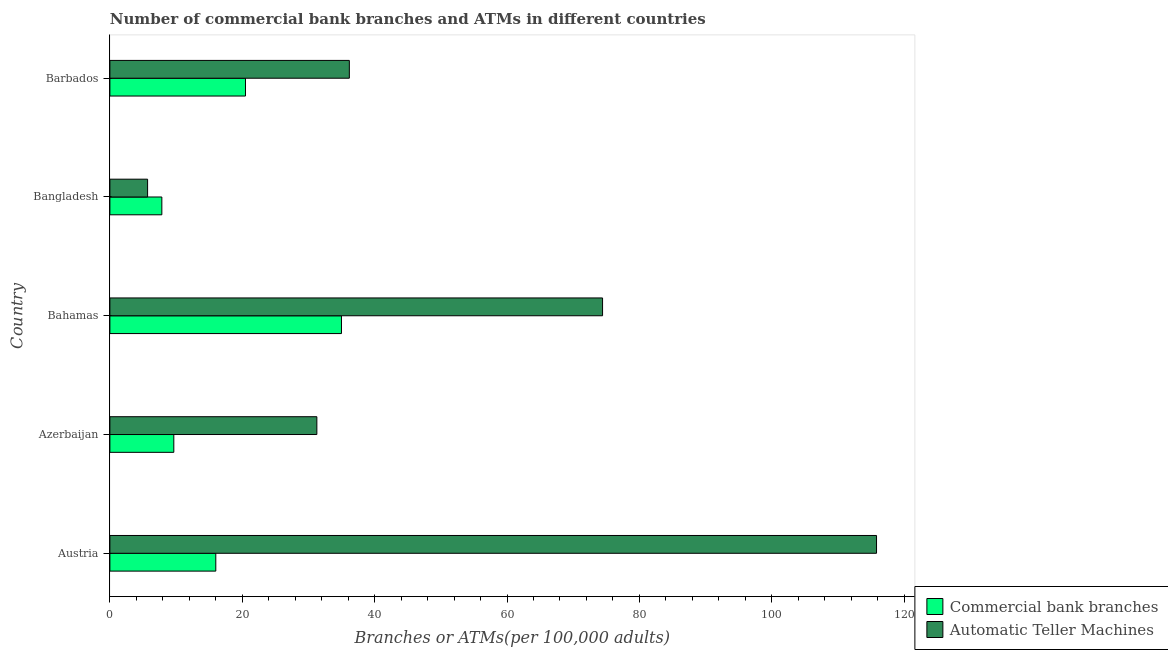How many groups of bars are there?
Offer a terse response. 5. Are the number of bars per tick equal to the number of legend labels?
Offer a very short reply. Yes. How many bars are there on the 2nd tick from the top?
Your answer should be very brief. 2. How many bars are there on the 2nd tick from the bottom?
Your answer should be very brief. 2. What is the label of the 5th group of bars from the top?
Your answer should be compact. Austria. What is the number of atms in Azerbaijan?
Provide a succinct answer. 31.27. Across all countries, what is the maximum number of commercal bank branches?
Your answer should be compact. 34.99. Across all countries, what is the minimum number of commercal bank branches?
Make the answer very short. 7.85. In which country was the number of commercal bank branches minimum?
Provide a short and direct response. Bangladesh. What is the total number of atms in the graph?
Offer a terse response. 263.4. What is the difference between the number of atms in Austria and that in Barbados?
Your response must be concise. 79.65. What is the difference between the number of atms in Azerbaijan and the number of commercal bank branches in Barbados?
Offer a terse response. 10.78. What is the average number of commercal bank branches per country?
Keep it short and to the point. 17.8. What is the difference between the number of commercal bank branches and number of atms in Austria?
Offer a terse response. -99.83. In how many countries, is the number of atms greater than 60 ?
Give a very brief answer. 2. What is the ratio of the number of commercal bank branches in Austria to that in Azerbaijan?
Your answer should be compact. 1.66. Is the number of atms in Austria less than that in Bahamas?
Provide a short and direct response. No. Is the difference between the number of atms in Austria and Barbados greater than the difference between the number of commercal bank branches in Austria and Barbados?
Make the answer very short. Yes. What is the difference between the highest and the second highest number of commercal bank branches?
Offer a very short reply. 14.5. What is the difference between the highest and the lowest number of commercal bank branches?
Offer a terse response. 27.14. In how many countries, is the number of atms greater than the average number of atms taken over all countries?
Offer a terse response. 2. Is the sum of the number of atms in Austria and Azerbaijan greater than the maximum number of commercal bank branches across all countries?
Ensure brevity in your answer.  Yes. What does the 1st bar from the top in Bangladesh represents?
Your response must be concise. Automatic Teller Machines. What does the 1st bar from the bottom in Barbados represents?
Ensure brevity in your answer.  Commercial bank branches. How many countries are there in the graph?
Provide a short and direct response. 5. Does the graph contain any zero values?
Make the answer very short. No. Does the graph contain grids?
Ensure brevity in your answer.  No. Where does the legend appear in the graph?
Give a very brief answer. Bottom right. How many legend labels are there?
Provide a succinct answer. 2. What is the title of the graph?
Keep it short and to the point. Number of commercial bank branches and ATMs in different countries. What is the label or title of the X-axis?
Your response must be concise. Branches or ATMs(per 100,0 adults). What is the Branches or ATMs(per 100,000 adults) in Commercial bank branches in Austria?
Keep it short and to the point. 16. What is the Branches or ATMs(per 100,000 adults) in Automatic Teller Machines in Austria?
Offer a very short reply. 115.83. What is the Branches or ATMs(per 100,000 adults) of Commercial bank branches in Azerbaijan?
Keep it short and to the point. 9.66. What is the Branches or ATMs(per 100,000 adults) of Automatic Teller Machines in Azerbaijan?
Give a very brief answer. 31.27. What is the Branches or ATMs(per 100,000 adults) of Commercial bank branches in Bahamas?
Your answer should be very brief. 34.99. What is the Branches or ATMs(per 100,000 adults) in Automatic Teller Machines in Bahamas?
Give a very brief answer. 74.43. What is the Branches or ATMs(per 100,000 adults) in Commercial bank branches in Bangladesh?
Provide a short and direct response. 7.85. What is the Branches or ATMs(per 100,000 adults) of Automatic Teller Machines in Bangladesh?
Ensure brevity in your answer.  5.7. What is the Branches or ATMs(per 100,000 adults) of Commercial bank branches in Barbados?
Provide a succinct answer. 20.49. What is the Branches or ATMs(per 100,000 adults) in Automatic Teller Machines in Barbados?
Offer a very short reply. 36.18. Across all countries, what is the maximum Branches or ATMs(per 100,000 adults) of Commercial bank branches?
Provide a short and direct response. 34.99. Across all countries, what is the maximum Branches or ATMs(per 100,000 adults) in Automatic Teller Machines?
Give a very brief answer. 115.83. Across all countries, what is the minimum Branches or ATMs(per 100,000 adults) of Commercial bank branches?
Provide a short and direct response. 7.85. Across all countries, what is the minimum Branches or ATMs(per 100,000 adults) in Automatic Teller Machines?
Offer a terse response. 5.7. What is the total Branches or ATMs(per 100,000 adults) in Commercial bank branches in the graph?
Provide a succinct answer. 88.98. What is the total Branches or ATMs(per 100,000 adults) of Automatic Teller Machines in the graph?
Ensure brevity in your answer.  263.4. What is the difference between the Branches or ATMs(per 100,000 adults) in Commercial bank branches in Austria and that in Azerbaijan?
Keep it short and to the point. 6.34. What is the difference between the Branches or ATMs(per 100,000 adults) in Automatic Teller Machines in Austria and that in Azerbaijan?
Ensure brevity in your answer.  84.56. What is the difference between the Branches or ATMs(per 100,000 adults) in Commercial bank branches in Austria and that in Bahamas?
Your answer should be very brief. -18.99. What is the difference between the Branches or ATMs(per 100,000 adults) of Automatic Teller Machines in Austria and that in Bahamas?
Your answer should be very brief. 41.39. What is the difference between the Branches or ATMs(per 100,000 adults) in Commercial bank branches in Austria and that in Bangladesh?
Give a very brief answer. 8.15. What is the difference between the Branches or ATMs(per 100,000 adults) in Automatic Teller Machines in Austria and that in Bangladesh?
Ensure brevity in your answer.  110.13. What is the difference between the Branches or ATMs(per 100,000 adults) in Commercial bank branches in Austria and that in Barbados?
Your response must be concise. -4.49. What is the difference between the Branches or ATMs(per 100,000 adults) in Automatic Teller Machines in Austria and that in Barbados?
Your response must be concise. 79.65. What is the difference between the Branches or ATMs(per 100,000 adults) of Commercial bank branches in Azerbaijan and that in Bahamas?
Make the answer very short. -25.33. What is the difference between the Branches or ATMs(per 100,000 adults) in Automatic Teller Machines in Azerbaijan and that in Bahamas?
Give a very brief answer. -43.17. What is the difference between the Branches or ATMs(per 100,000 adults) of Commercial bank branches in Azerbaijan and that in Bangladesh?
Give a very brief answer. 1.81. What is the difference between the Branches or ATMs(per 100,000 adults) in Automatic Teller Machines in Azerbaijan and that in Bangladesh?
Your response must be concise. 25.57. What is the difference between the Branches or ATMs(per 100,000 adults) of Commercial bank branches in Azerbaijan and that in Barbados?
Your response must be concise. -10.83. What is the difference between the Branches or ATMs(per 100,000 adults) in Automatic Teller Machines in Azerbaijan and that in Barbados?
Offer a terse response. -4.91. What is the difference between the Branches or ATMs(per 100,000 adults) of Commercial bank branches in Bahamas and that in Bangladesh?
Give a very brief answer. 27.14. What is the difference between the Branches or ATMs(per 100,000 adults) in Automatic Teller Machines in Bahamas and that in Bangladesh?
Give a very brief answer. 68.74. What is the difference between the Branches or ATMs(per 100,000 adults) in Commercial bank branches in Bahamas and that in Barbados?
Provide a short and direct response. 14.5. What is the difference between the Branches or ATMs(per 100,000 adults) of Automatic Teller Machines in Bahamas and that in Barbados?
Make the answer very short. 38.26. What is the difference between the Branches or ATMs(per 100,000 adults) in Commercial bank branches in Bangladesh and that in Barbados?
Provide a succinct answer. -12.64. What is the difference between the Branches or ATMs(per 100,000 adults) in Automatic Teller Machines in Bangladesh and that in Barbados?
Ensure brevity in your answer.  -30.48. What is the difference between the Branches or ATMs(per 100,000 adults) in Commercial bank branches in Austria and the Branches or ATMs(per 100,000 adults) in Automatic Teller Machines in Azerbaijan?
Your answer should be compact. -15.27. What is the difference between the Branches or ATMs(per 100,000 adults) in Commercial bank branches in Austria and the Branches or ATMs(per 100,000 adults) in Automatic Teller Machines in Bahamas?
Your response must be concise. -58.43. What is the difference between the Branches or ATMs(per 100,000 adults) in Commercial bank branches in Austria and the Branches or ATMs(per 100,000 adults) in Automatic Teller Machines in Bangladesh?
Keep it short and to the point. 10.3. What is the difference between the Branches or ATMs(per 100,000 adults) of Commercial bank branches in Austria and the Branches or ATMs(per 100,000 adults) of Automatic Teller Machines in Barbados?
Your response must be concise. -20.18. What is the difference between the Branches or ATMs(per 100,000 adults) of Commercial bank branches in Azerbaijan and the Branches or ATMs(per 100,000 adults) of Automatic Teller Machines in Bahamas?
Keep it short and to the point. -64.78. What is the difference between the Branches or ATMs(per 100,000 adults) in Commercial bank branches in Azerbaijan and the Branches or ATMs(per 100,000 adults) in Automatic Teller Machines in Bangladesh?
Your answer should be very brief. 3.96. What is the difference between the Branches or ATMs(per 100,000 adults) of Commercial bank branches in Azerbaijan and the Branches or ATMs(per 100,000 adults) of Automatic Teller Machines in Barbados?
Give a very brief answer. -26.52. What is the difference between the Branches or ATMs(per 100,000 adults) in Commercial bank branches in Bahamas and the Branches or ATMs(per 100,000 adults) in Automatic Teller Machines in Bangladesh?
Keep it short and to the point. 29.29. What is the difference between the Branches or ATMs(per 100,000 adults) of Commercial bank branches in Bahamas and the Branches or ATMs(per 100,000 adults) of Automatic Teller Machines in Barbados?
Make the answer very short. -1.19. What is the difference between the Branches or ATMs(per 100,000 adults) of Commercial bank branches in Bangladesh and the Branches or ATMs(per 100,000 adults) of Automatic Teller Machines in Barbados?
Keep it short and to the point. -28.33. What is the average Branches or ATMs(per 100,000 adults) in Commercial bank branches per country?
Provide a short and direct response. 17.8. What is the average Branches or ATMs(per 100,000 adults) of Automatic Teller Machines per country?
Keep it short and to the point. 52.68. What is the difference between the Branches or ATMs(per 100,000 adults) of Commercial bank branches and Branches or ATMs(per 100,000 adults) of Automatic Teller Machines in Austria?
Provide a succinct answer. -99.83. What is the difference between the Branches or ATMs(per 100,000 adults) in Commercial bank branches and Branches or ATMs(per 100,000 adults) in Automatic Teller Machines in Azerbaijan?
Offer a terse response. -21.61. What is the difference between the Branches or ATMs(per 100,000 adults) of Commercial bank branches and Branches or ATMs(per 100,000 adults) of Automatic Teller Machines in Bahamas?
Offer a terse response. -39.45. What is the difference between the Branches or ATMs(per 100,000 adults) of Commercial bank branches and Branches or ATMs(per 100,000 adults) of Automatic Teller Machines in Bangladesh?
Provide a short and direct response. 2.15. What is the difference between the Branches or ATMs(per 100,000 adults) of Commercial bank branches and Branches or ATMs(per 100,000 adults) of Automatic Teller Machines in Barbados?
Your answer should be compact. -15.69. What is the ratio of the Branches or ATMs(per 100,000 adults) in Commercial bank branches in Austria to that in Azerbaijan?
Your answer should be very brief. 1.66. What is the ratio of the Branches or ATMs(per 100,000 adults) of Automatic Teller Machines in Austria to that in Azerbaijan?
Your answer should be compact. 3.7. What is the ratio of the Branches or ATMs(per 100,000 adults) in Commercial bank branches in Austria to that in Bahamas?
Your answer should be very brief. 0.46. What is the ratio of the Branches or ATMs(per 100,000 adults) in Automatic Teller Machines in Austria to that in Bahamas?
Make the answer very short. 1.56. What is the ratio of the Branches or ATMs(per 100,000 adults) in Commercial bank branches in Austria to that in Bangladesh?
Offer a very short reply. 2.04. What is the ratio of the Branches or ATMs(per 100,000 adults) in Automatic Teller Machines in Austria to that in Bangladesh?
Make the answer very short. 20.34. What is the ratio of the Branches or ATMs(per 100,000 adults) in Commercial bank branches in Austria to that in Barbados?
Provide a succinct answer. 0.78. What is the ratio of the Branches or ATMs(per 100,000 adults) of Automatic Teller Machines in Austria to that in Barbados?
Make the answer very short. 3.2. What is the ratio of the Branches or ATMs(per 100,000 adults) in Commercial bank branches in Azerbaijan to that in Bahamas?
Your answer should be very brief. 0.28. What is the ratio of the Branches or ATMs(per 100,000 adults) of Automatic Teller Machines in Azerbaijan to that in Bahamas?
Ensure brevity in your answer.  0.42. What is the ratio of the Branches or ATMs(per 100,000 adults) in Commercial bank branches in Azerbaijan to that in Bangladesh?
Offer a very short reply. 1.23. What is the ratio of the Branches or ATMs(per 100,000 adults) of Automatic Teller Machines in Azerbaijan to that in Bangladesh?
Your response must be concise. 5.49. What is the ratio of the Branches or ATMs(per 100,000 adults) of Commercial bank branches in Azerbaijan to that in Barbados?
Keep it short and to the point. 0.47. What is the ratio of the Branches or ATMs(per 100,000 adults) of Automatic Teller Machines in Azerbaijan to that in Barbados?
Keep it short and to the point. 0.86. What is the ratio of the Branches or ATMs(per 100,000 adults) of Commercial bank branches in Bahamas to that in Bangladesh?
Ensure brevity in your answer.  4.46. What is the ratio of the Branches or ATMs(per 100,000 adults) in Automatic Teller Machines in Bahamas to that in Bangladesh?
Offer a very short reply. 13.07. What is the ratio of the Branches or ATMs(per 100,000 adults) in Commercial bank branches in Bahamas to that in Barbados?
Offer a terse response. 1.71. What is the ratio of the Branches or ATMs(per 100,000 adults) of Automatic Teller Machines in Bahamas to that in Barbados?
Ensure brevity in your answer.  2.06. What is the ratio of the Branches or ATMs(per 100,000 adults) in Commercial bank branches in Bangladesh to that in Barbados?
Ensure brevity in your answer.  0.38. What is the ratio of the Branches or ATMs(per 100,000 adults) of Automatic Teller Machines in Bangladesh to that in Barbados?
Ensure brevity in your answer.  0.16. What is the difference between the highest and the second highest Branches or ATMs(per 100,000 adults) of Commercial bank branches?
Provide a short and direct response. 14.5. What is the difference between the highest and the second highest Branches or ATMs(per 100,000 adults) in Automatic Teller Machines?
Make the answer very short. 41.39. What is the difference between the highest and the lowest Branches or ATMs(per 100,000 adults) in Commercial bank branches?
Give a very brief answer. 27.14. What is the difference between the highest and the lowest Branches or ATMs(per 100,000 adults) of Automatic Teller Machines?
Keep it short and to the point. 110.13. 